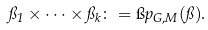Convert formula to latex. <formula><loc_0><loc_0><loc_500><loc_500>\pi _ { 1 } \times \cdots \times \pi _ { k } \colon = \i p _ { G , M } ( \pi ) .</formula> 